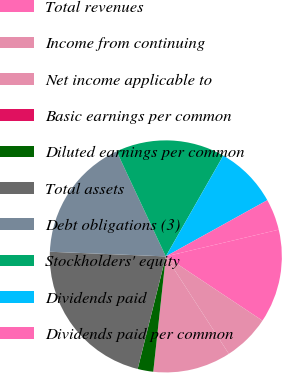<chart> <loc_0><loc_0><loc_500><loc_500><pie_chart><fcel>Total revenues<fcel>Income from continuing<fcel>Net income applicable to<fcel>Basic earnings per common<fcel>Diluted earnings per common<fcel>Total assets<fcel>Debt obligations (3)<fcel>Stockholders' equity<fcel>Dividends paid<fcel>Dividends paid per common<nl><fcel>13.04%<fcel>6.52%<fcel>10.87%<fcel>0.0%<fcel>2.17%<fcel>21.74%<fcel>17.39%<fcel>15.22%<fcel>8.7%<fcel>4.35%<nl></chart> 